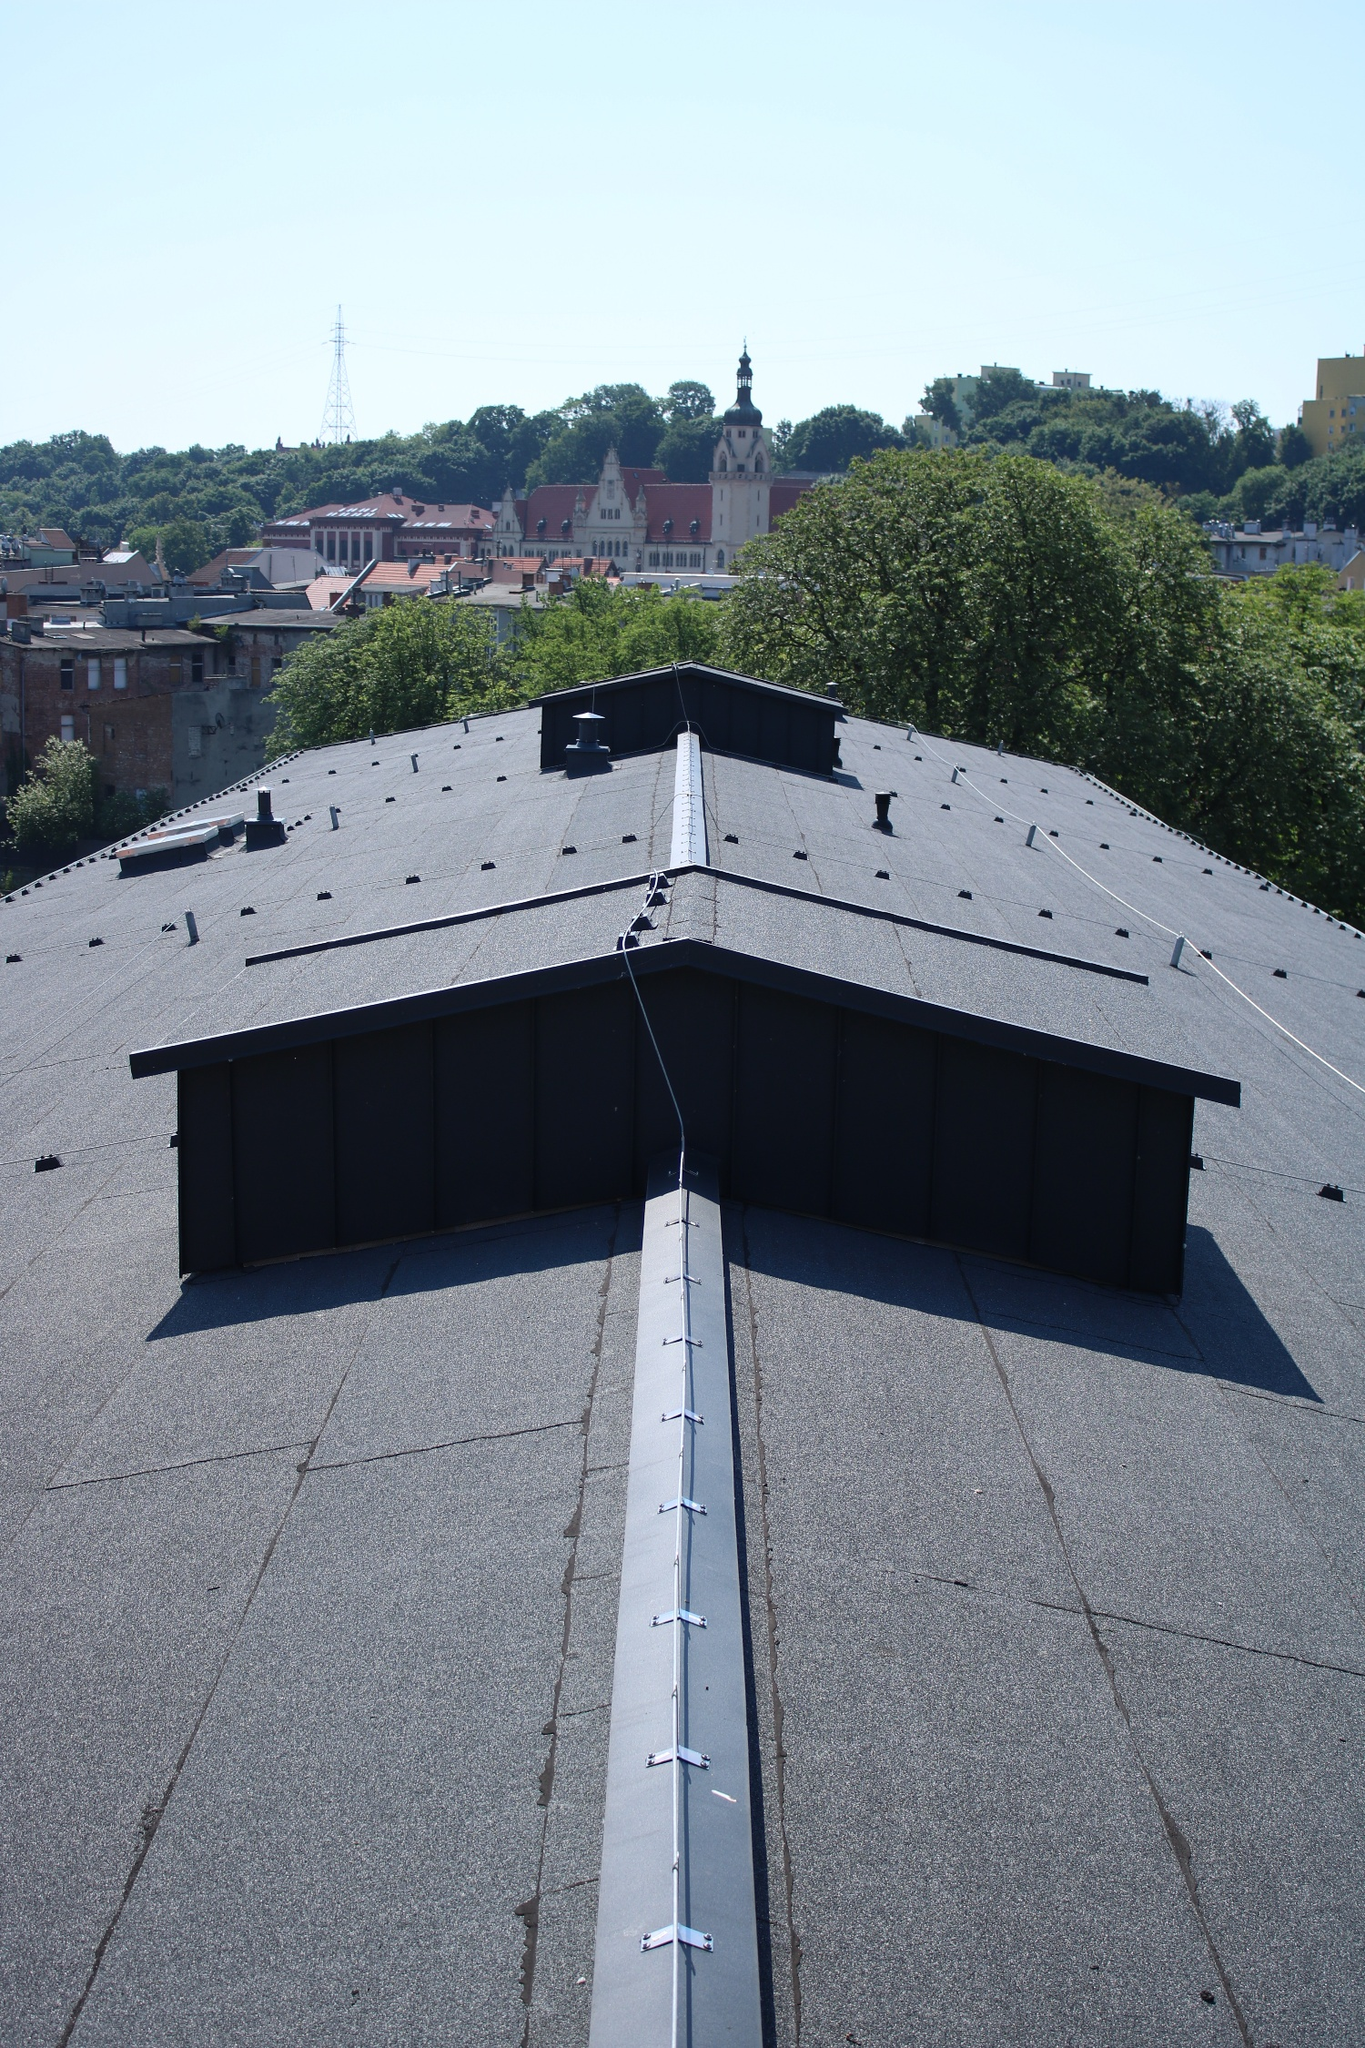Does the image evoke any particular season or time of year? The image conveys an essence of late spring or early summer. The clear blue sky and bright sunlight, along with the lush greenery on the trees, suggest a time of year when nature is in full bloom. The lighting is sharp and vibrant, typical of warm, sunny days. There are no indications of autumnal colors or winter elements, such as snow or bare branches, reinforcing the impression of a warmer season. How might the scene change during autumn? During autumn, the cityscape would transform into a symphony of warm colors. The lush green trees would adopt shades of gold, orange, and red, creating a vibrant contrast against the rooftops and buildings. The clear blue sky might be streaked with soft hues of pink and orange during sunset, adding a gentle warmth to the atmosphere. Leaves would blanket the streets and rooftops, and the cool, crisp air would usher in a sense of tranquility. The architectural details of the buildings might stand out more prominently against the backdrop of fall foliage, giving the cityscape a picturesque and nostalgic charm. 